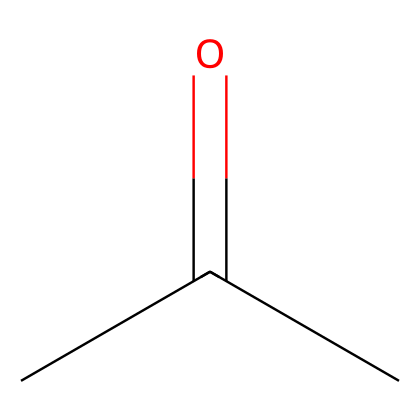What is the chemical name of this compound? The SMILES representation "CC(=O)C" corresponds to acetone, which is a common name for the compound with this structure.
Answer: acetone How many carbon atoms are in acetone? By analyzing the SMILES representation "CC(=O)C", we can identify three carbon atoms (the two "C" in the beginning and one "C" at the end, along with the carbon in the carbonyl group).
Answer: three What type of functional group is present in acetone? The presence of "C=O" in the structure indicates a carbonyl functional group, which is characteristic of ketones. Since acetone has a carbonyl group flanked by carbon atoms, it is classified as a ketone.
Answer: ketone What is the total number of hydrogen atoms in acetone? In the SMILES representation "CC(=O)C", each carbon can have up to four bonds. The first and last carbon each contribute three hydrogens, and the middle carbon has one hydrogen, resulting in a total of six hydrogen atoms.
Answer: six Is acetone polar or nonpolar? Acetone has a polar bond due to the electronegativity difference between carbon and oxygen in the carbonyl group, and this contributes to the molecule's overall polarity, making it a polar solvent.
Answer: polar Identify the primary use of acetone in electronics. Acetone is commonly used as a solvent for cleaning electronic components, making it suitable for removing oils, greases, and residues.
Answer: cleaning solvent 